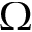<formula> <loc_0><loc_0><loc_500><loc_500>\Omega</formula> 